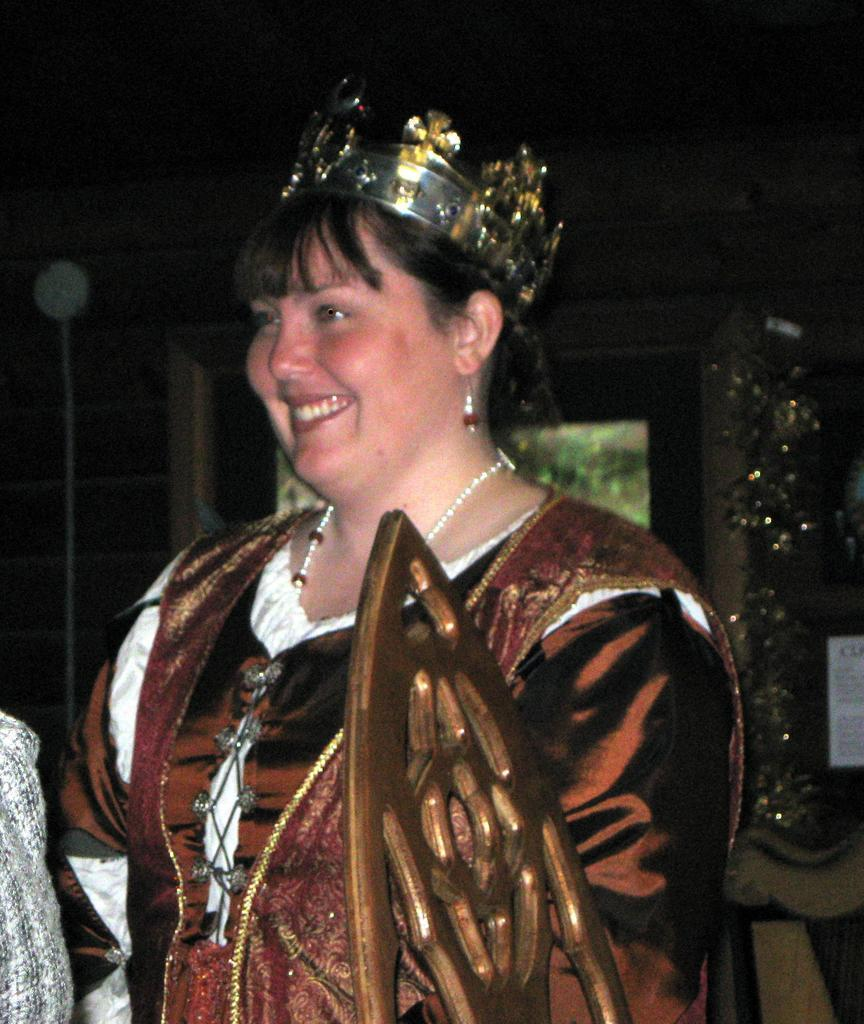Who is present in the image? There is a woman in the image. What is the woman's facial expression? The woman is smiling. What is the woman wearing on her head? The woman is wearing a crown. What can be seen in the background of the image? The background of the image is dark, and there is a wall visible. What type of milk is the woman using to wash her face in the image? There is no milk or washing activity present in the image. 